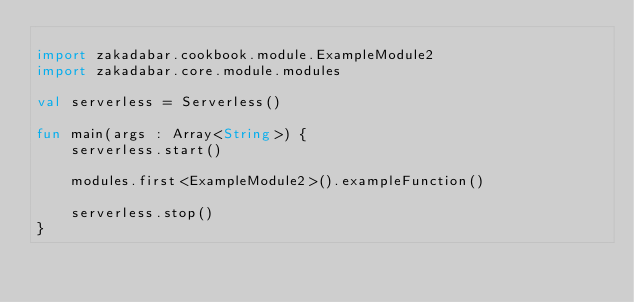Convert code to text. <code><loc_0><loc_0><loc_500><loc_500><_Kotlin_>
import zakadabar.cookbook.module.ExampleModule2
import zakadabar.core.module.modules

val serverless = Serverless()

fun main(args : Array<String>) {
    serverless.start()

    modules.first<ExampleModule2>().exampleFunction()

    serverless.stop()
}</code> 